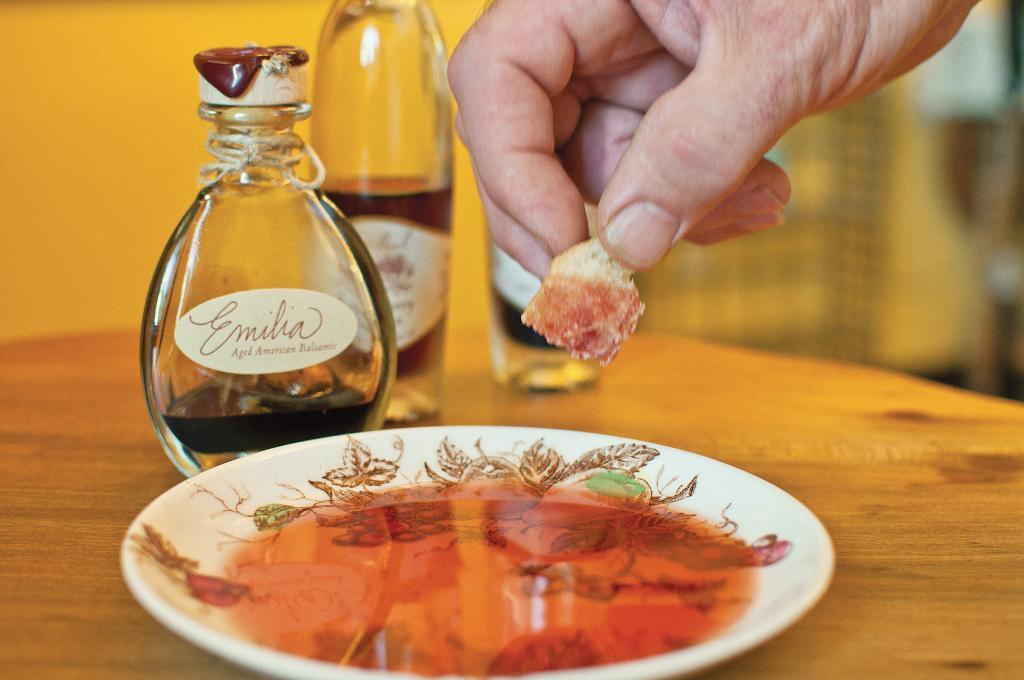Provide a one-sentence caption for the provided image. A piece of bread is dipped into Emilia brand balsamic oil. 